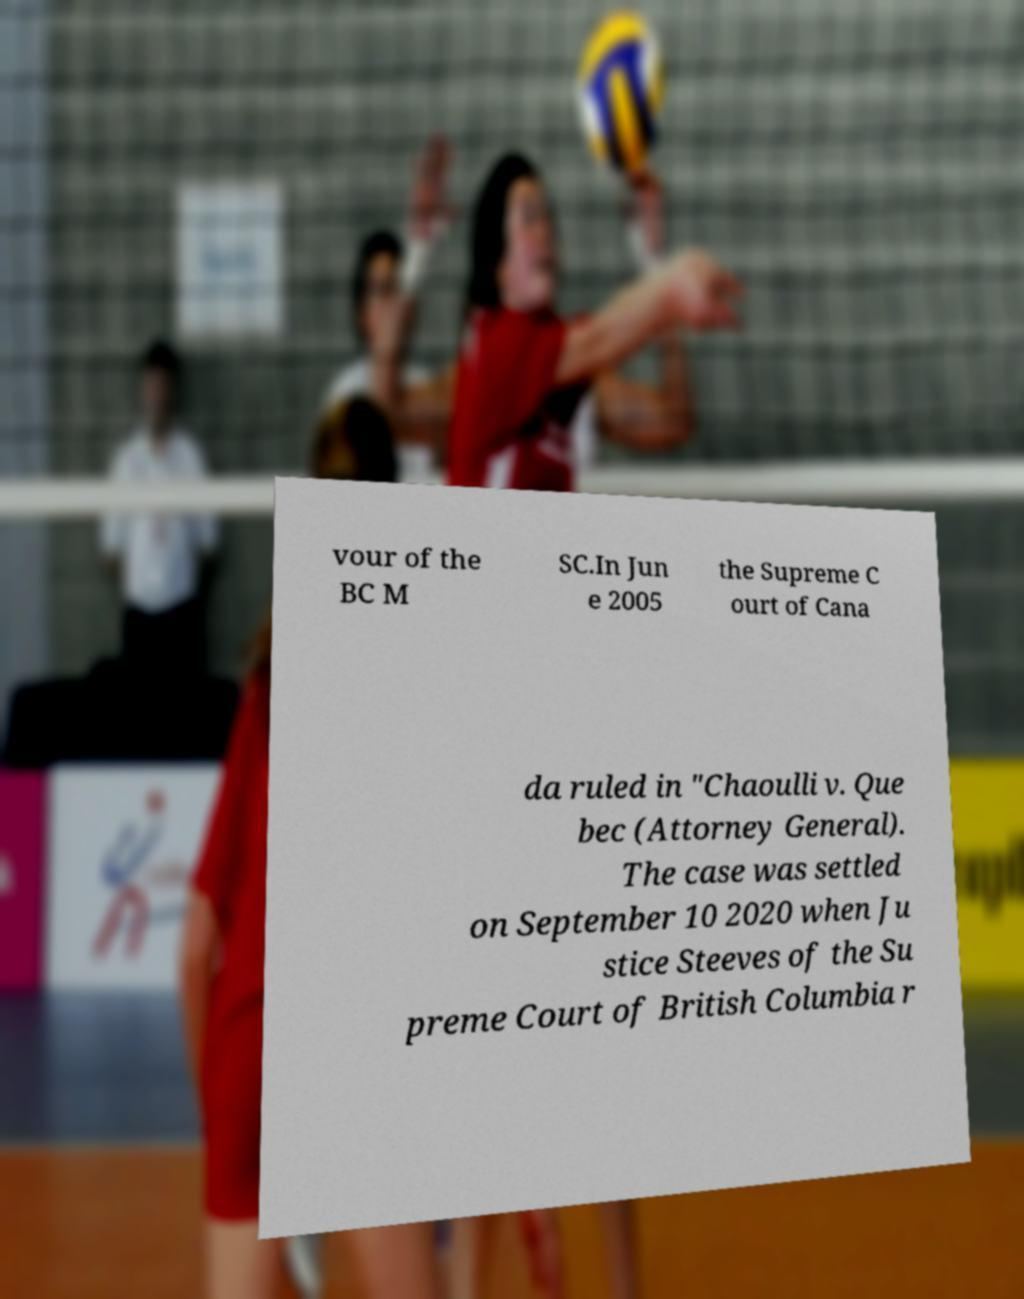For documentation purposes, I need the text within this image transcribed. Could you provide that? vour of the BC M SC.In Jun e 2005 the Supreme C ourt of Cana da ruled in "Chaoulli v. Que bec (Attorney General). The case was settled on September 10 2020 when Ju stice Steeves of the Su preme Court of British Columbia r 